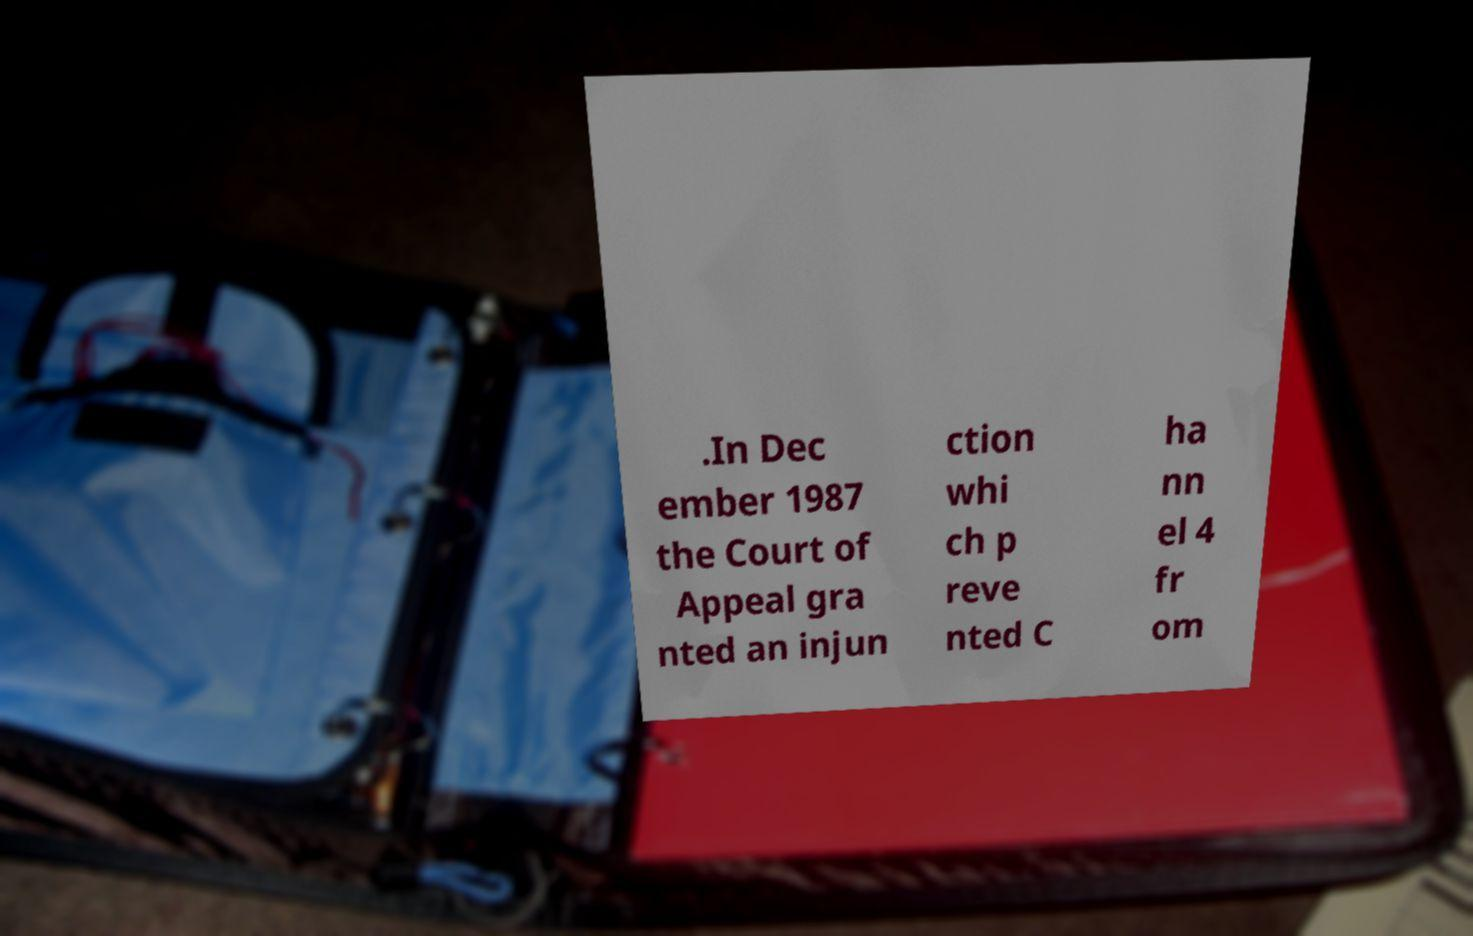There's text embedded in this image that I need extracted. Can you transcribe it verbatim? .In Dec ember 1987 the Court of Appeal gra nted an injun ction whi ch p reve nted C ha nn el 4 fr om 